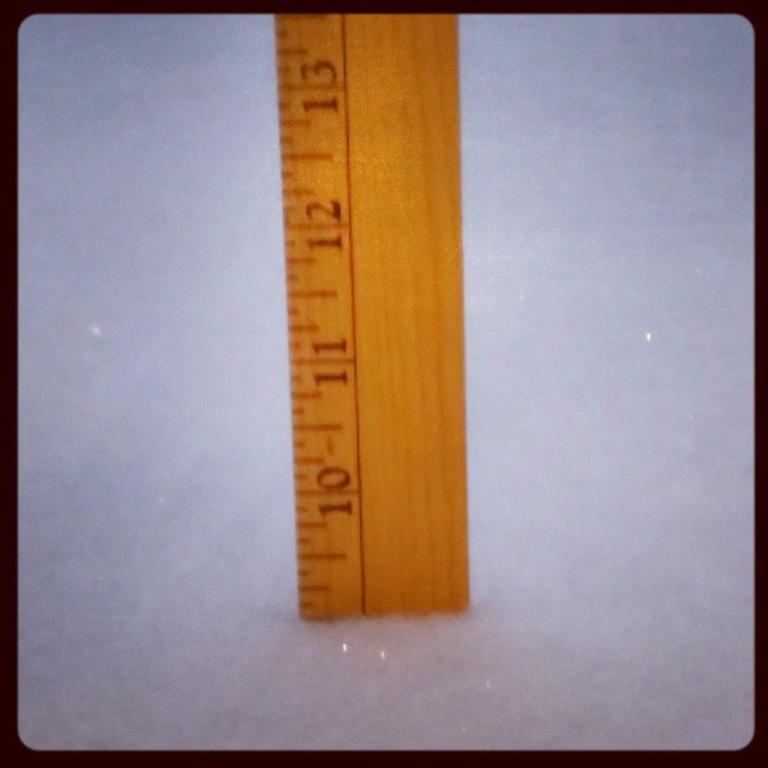<image>
Relay a brief, clear account of the picture shown. A ruler that is showing that the snow is over nine inches deep because we see that the numbers 10, 11, 12 and 13 are showing. 